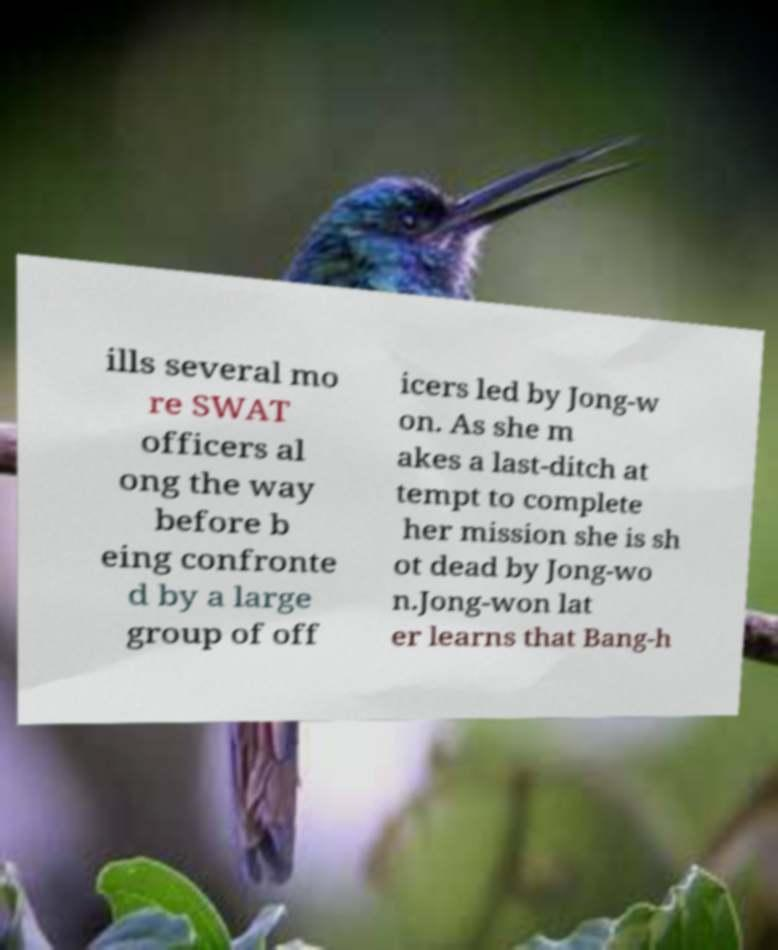There's text embedded in this image that I need extracted. Can you transcribe it verbatim? ills several mo re SWAT officers al ong the way before b eing confronte d by a large group of off icers led by Jong-w on. As she m akes a last-ditch at tempt to complete her mission she is sh ot dead by Jong-wo n.Jong-won lat er learns that Bang-h 